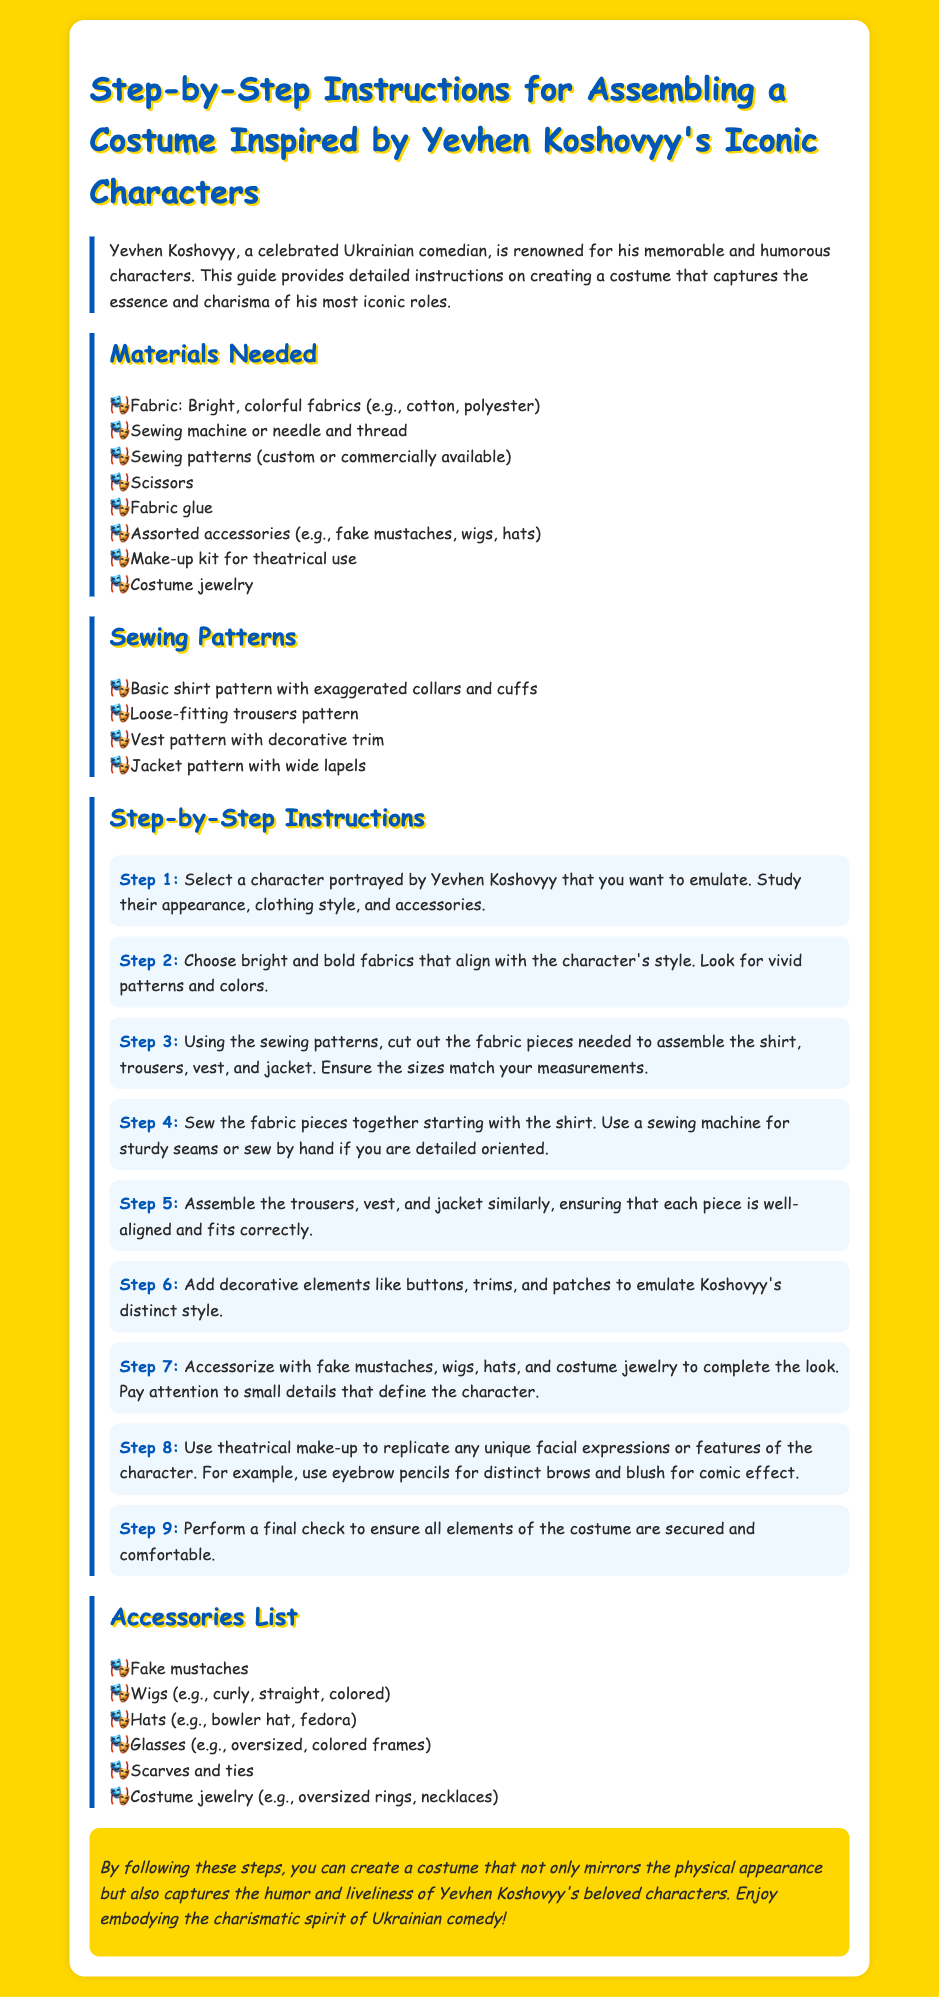What is Yevhen Koshovyy known for? Yevhen Koshovyy is celebrated for his memorable and humorous characters in Ukrainian comedy.
Answer: Ukrainian comedy What type of sewing patterns are recommended? The document lists specific sewing patterns including a basic shirt pattern, loose-fitting trousers pattern, vest pattern, and jacket pattern.
Answer: Basic shirt, trousers, vest, jacket What is the first step in assembling the costume? The first step involves selecting a character portrayed by Yevhen Koshovyy to emulate.
Answer: Select a character How many steps are there in the assembly instructions? The instructions detail a total of nine steps for assembling the costume.
Answer: Nine steps What type of fabric is recommended for the costume? The document suggests using bright, colorful fabrics such as cotton or polyester.
Answer: Bright, colorful fabrics What accessories are listed for completing the costume? The document mentions accessories like fake mustaches, wigs, hats, and costume jewelry.
Answer: Fake mustaches, wigs, hats, jewelry What is emphasized to ensure in the final step? The final step emphasizes performing a check to ensure all elements of the costume are secured and comfortable.
Answer: Final check Which makeup is advised for the costume? The document recommends using a theatrical makeup kit to replicate unique facial expressions or features.
Answer: Theatrical makeup 